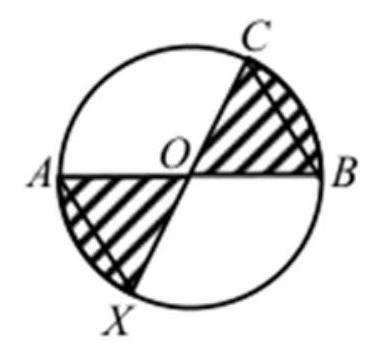If angle OBC is 45 degrees, how does that help determine the area of the shaded sections? Knowing angle OBC is 45 degrees is crucial as it indicates that the triangle OBC occupies an eighth of the circle's area because the full circle encompasses 360 degrees, and a 45-degree angle corresponds to an eighth of that. Each shaded section is a quarter-circle from which this eighth of a circle (the area of the triangle OBC) must be subtracted. Since there are two shaded sections, the combined shaded area would be half of the circle minus two triangle areas, or in other terms, half of the circle minus a quarter of the circle, leaving us with a quarter of the circle shaded. To find the fraction, we would then need to compare this area with the options provided. 